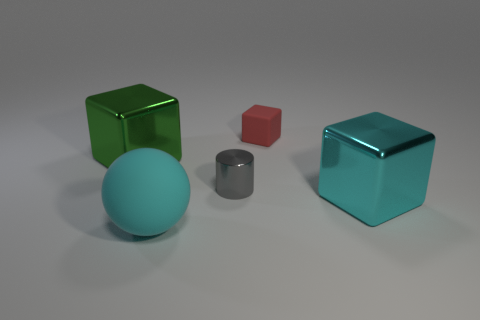Subtract all red matte blocks. How many blocks are left? 2 Subtract all red blocks. How many blocks are left? 2 Subtract all gray blocks. Subtract all purple balls. How many blocks are left? 3 Add 2 large cyan balls. How many objects exist? 7 Subtract all cubes. How many objects are left? 2 Subtract all tiny cylinders. Subtract all small objects. How many objects are left? 2 Add 4 cylinders. How many cylinders are left? 5 Add 2 large matte balls. How many large matte balls exist? 3 Subtract 0 gray blocks. How many objects are left? 5 